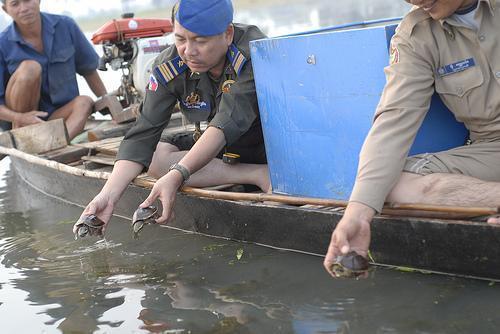How many people are wearing watch?
Give a very brief answer. 1. 